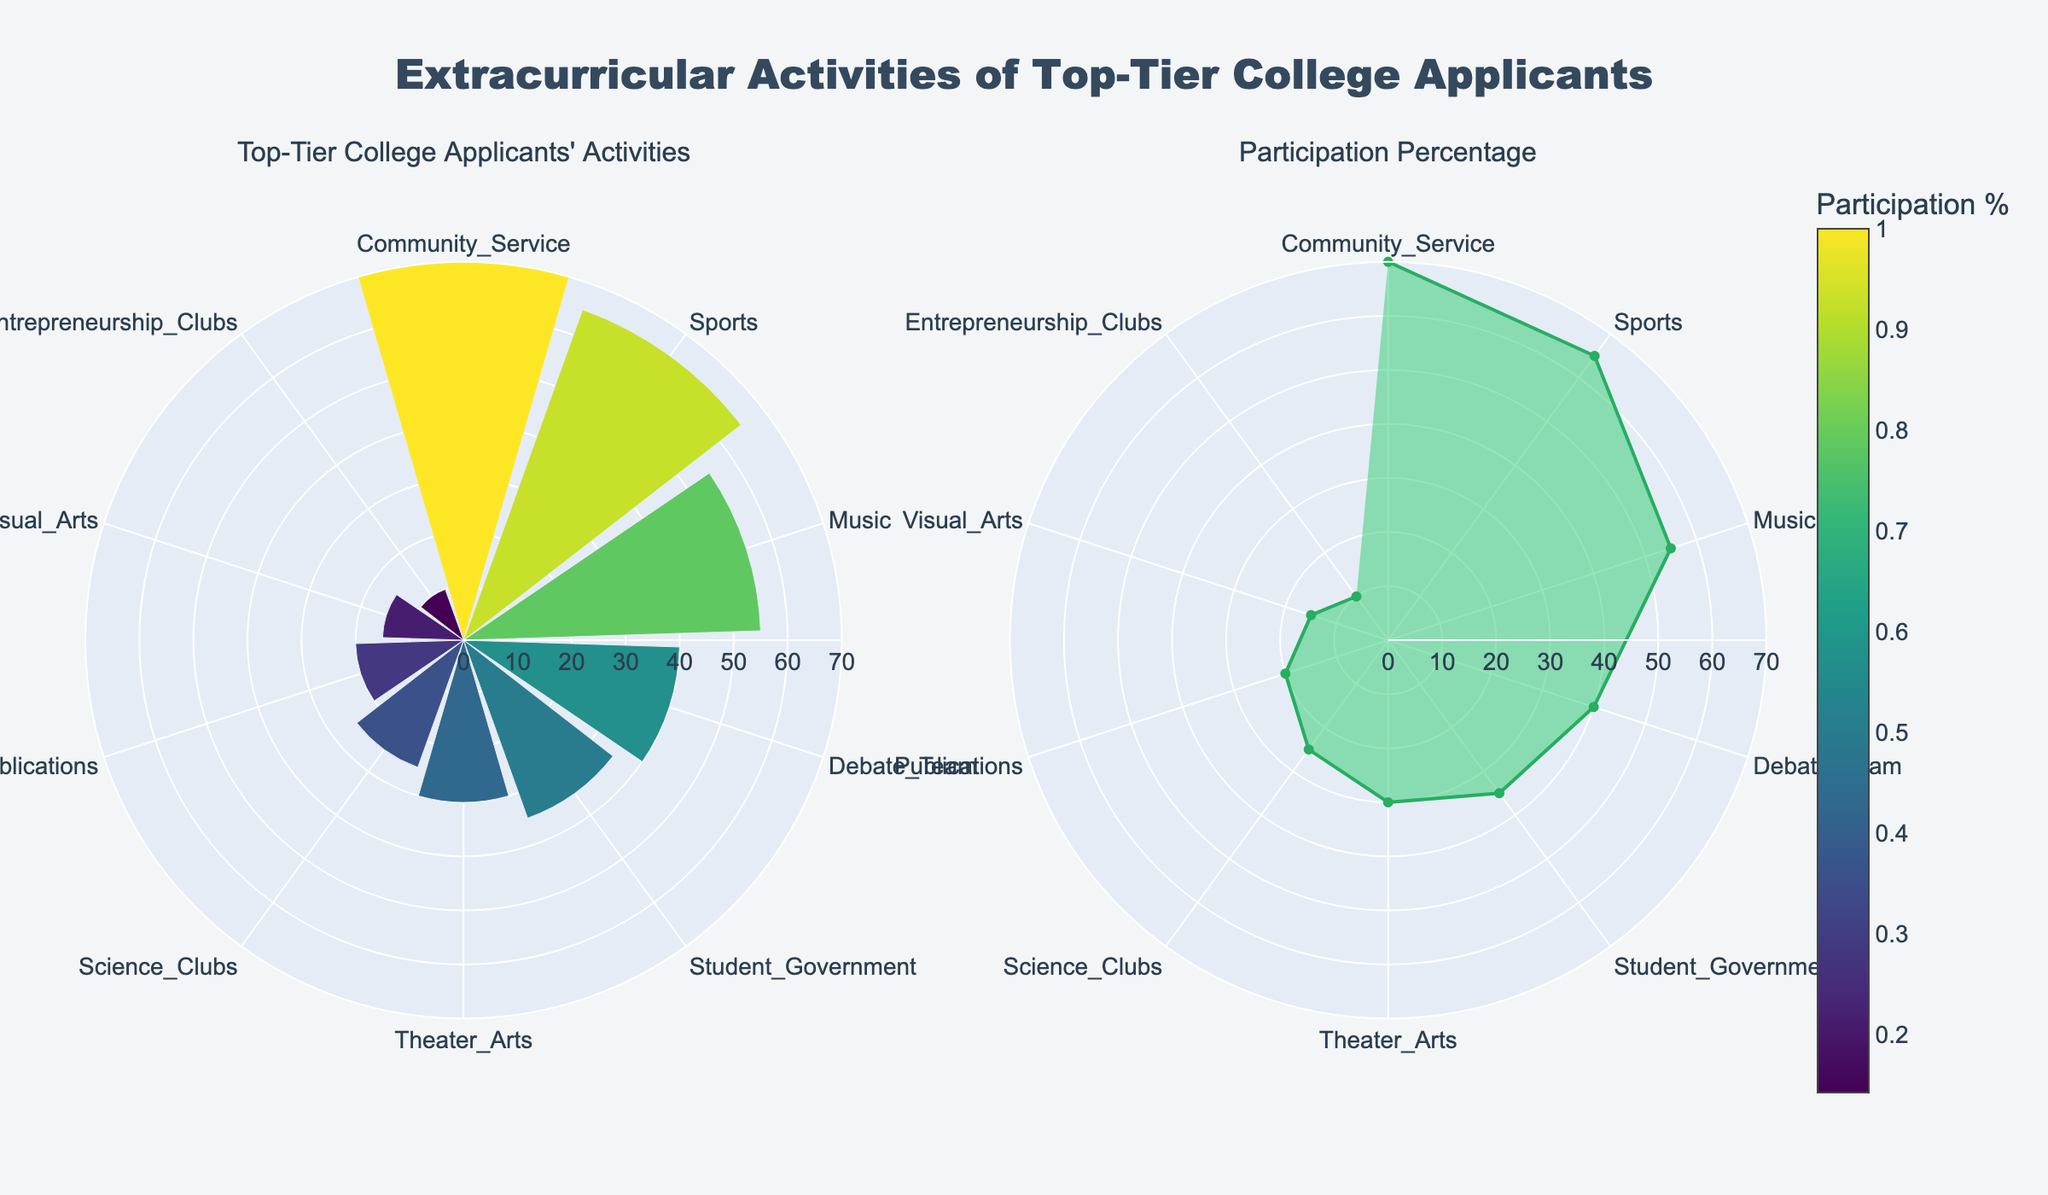What is the title of the figure? The title of the figure is located at the top center. It states "Extracurricular Activities of Top-Tier College Applicants."
Answer: Extracurricular Activities of Top-Tier College Applicants Which activity has the highest percentage of participants? By inspecting the figure, the activity with the largest radial length in both subplots is Community Service.
Answer: Community Service Identify the two activities with the lowest participation percentage. Looking at the smallest radial lengths, Visual Arts and Entrepreneurship Clubs have the lowest percentages in both subplots.
Answer: Visual Arts and Entrepreneurship Clubs What is the percentage of participants in Sports? Refer to the lengths of the bars in the first subplot or the area in the second subplot. The percentage for Sports is marked as 65%.
Answer: 65% How does the participation in Publications compare to Science Clubs? By comparing radial lengths or areas, Publications (20%) has a lower participation rate than Science Clubs (25%).
Answer: Publications: 20%, Science Clubs: 25% What is the approximate difference in participation percentages between Music and Theater Arts? Music has 55% and Theater Arts has 30%, subtracting the latter from the former gives 55% - 30% = 25%.
Answer: 25% What's the average participation percentage for Debate Team, Student Government, and Theater Arts? Add the percentages for Debate Team (40%), Student Government (35%), and Theater Arts (30%), then divide by 3: (40 + 35 + 30) / 3 = 35%.
Answer: 35% Which activity has a participation percentage closest to the median value among all activities? Arranging percentages in ascending order: 10, 15, 20, 25, 30, 35, 40, 55, 65, 70. The median (middle value) is the average of 30 and 35, which is 32.5%. Student Government, with 35%, is closest to this median.
Answer: Student Government Which activity appears in green in the second subplot? The second subplot uses a green fill color ('rgba(46, 204, 113, 0.5)'), which is consistently applied to the outline of the graph. There are no specific green-highlighted areas per activity.
Answer: None What is the total number of activities represented in the figure? Counting the number of data points or unique activities represented in both subplots gives a total of 10 activities.
Answer: 10 